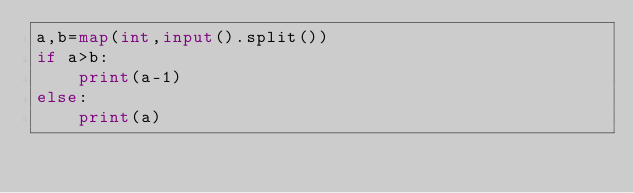<code> <loc_0><loc_0><loc_500><loc_500><_Python_>a,b=map(int,input().split())
if a>b:
    print(a-1)
else:
    print(a)</code> 